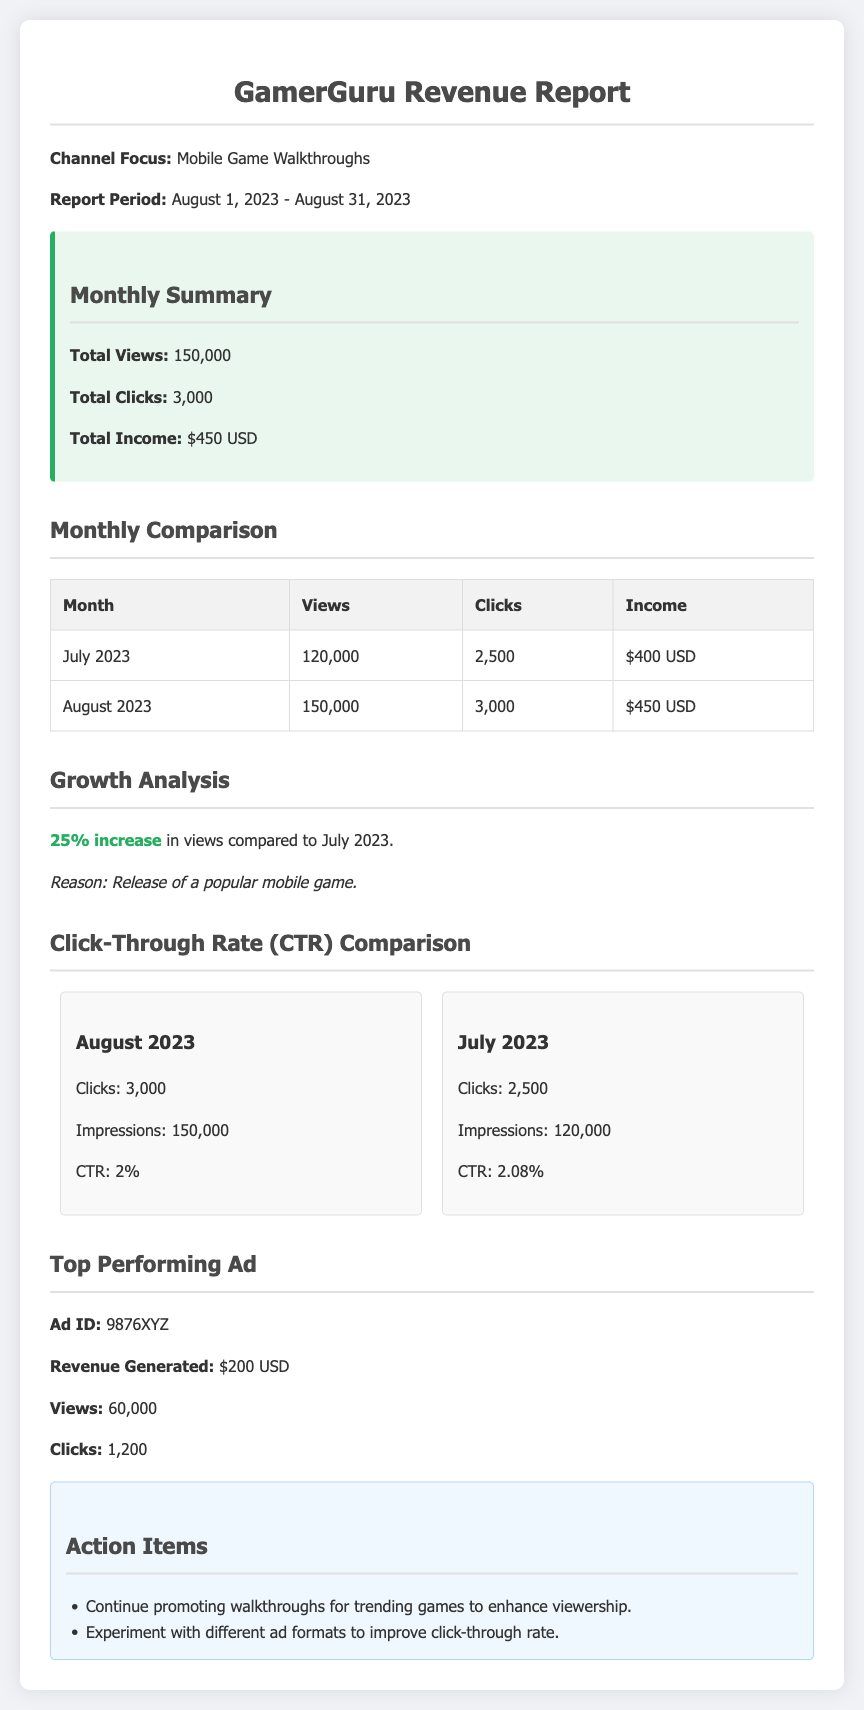What is the report period? The report period is specified in the document as the duration covered by the revenue report, which is from August 1, 2023, to August 31, 2023.
Answer: August 1, 2023 - August 31, 2023 What was the total income in August 2023? Total income for August 2023 is provided in the summary section of the document, stating the revenue generated for that month.
Answer: $450 USD How many total views were there in July 2023? The total views for July 2023 are listed in the monthly comparison table, specifically showing the data for that month.
Answer: 120,000 What percentage increase in views is reported? The growth analysis section indicates the percentage increase in views by comparing August with July, providing an overview of growth.
Answer: 25% What was the Click-Through Rate (CTR) for July 2023? The CTR for July 2023 is noted in the CTR comparison section, which explicitly states the rate for that month.
Answer: 2.08% What is the revenue generated by the top-performing ad? The document highlights the revenue generated from the top ad, detailing its impact on overall income.
Answer: $200 USD What action item is suggested regarding ad formats? The action items section offers suggestions for improving performance, including recommendations on ad formats.
Answer: Experiment with different ad formats to improve click-through rate How many clicks were recorded in August 2023? Clicks for August 2023 are summarized in both the monthly summary and the CTR comparison section of the document.
Answer: 3,000 